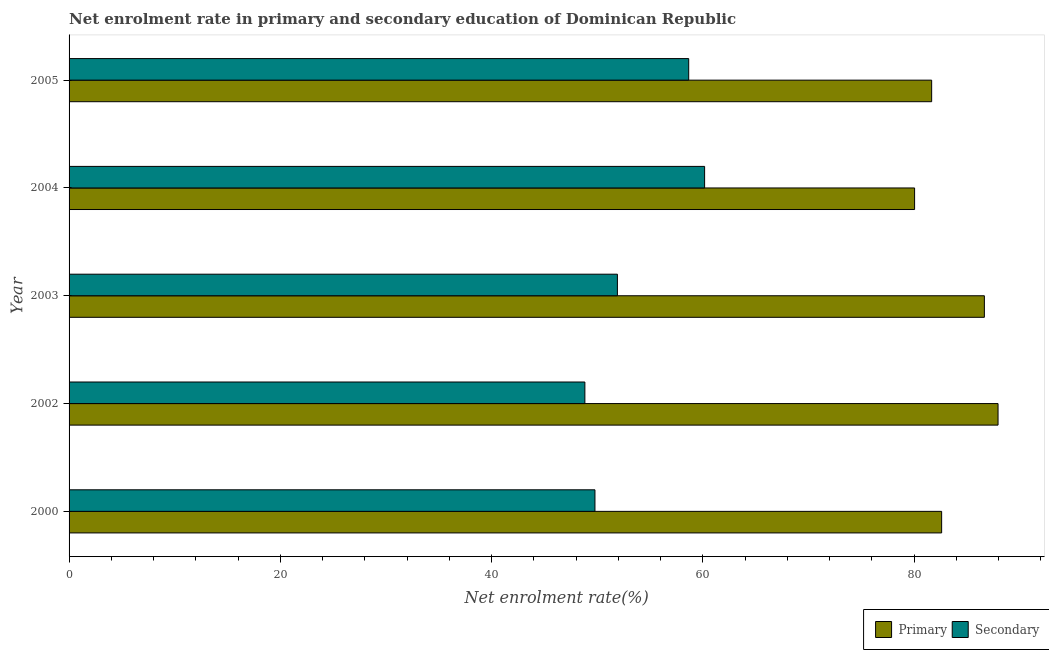What is the label of the 3rd group of bars from the top?
Offer a terse response. 2003. In how many cases, is the number of bars for a given year not equal to the number of legend labels?
Ensure brevity in your answer.  0. What is the enrollment rate in secondary education in 2005?
Offer a very short reply. 58.66. Across all years, what is the maximum enrollment rate in secondary education?
Provide a short and direct response. 60.16. Across all years, what is the minimum enrollment rate in secondary education?
Your response must be concise. 48.83. In which year was the enrollment rate in primary education maximum?
Provide a succinct answer. 2002. What is the total enrollment rate in primary education in the graph?
Offer a terse response. 418.88. What is the difference between the enrollment rate in primary education in 2004 and that in 2005?
Ensure brevity in your answer.  -1.61. What is the difference between the enrollment rate in primary education in 2000 and the enrollment rate in secondary education in 2005?
Provide a short and direct response. 23.94. What is the average enrollment rate in primary education per year?
Keep it short and to the point. 83.78. In the year 2005, what is the difference between the enrollment rate in primary education and enrollment rate in secondary education?
Offer a terse response. 23. In how many years, is the enrollment rate in primary education greater than 80 %?
Offer a terse response. 5. What is the ratio of the enrollment rate in primary education in 2002 to that in 2005?
Give a very brief answer. 1.08. Is the difference between the enrollment rate in secondary education in 2000 and 2004 greater than the difference between the enrollment rate in primary education in 2000 and 2004?
Make the answer very short. No. What is the difference between the highest and the second highest enrollment rate in primary education?
Provide a succinct answer. 1.29. What is the difference between the highest and the lowest enrollment rate in secondary education?
Provide a short and direct response. 11.33. Is the sum of the enrollment rate in primary education in 2002 and 2005 greater than the maximum enrollment rate in secondary education across all years?
Make the answer very short. Yes. What does the 2nd bar from the top in 2002 represents?
Provide a short and direct response. Primary. What does the 2nd bar from the bottom in 2004 represents?
Ensure brevity in your answer.  Secondary. Are all the bars in the graph horizontal?
Keep it short and to the point. Yes. What is the difference between two consecutive major ticks on the X-axis?
Provide a succinct answer. 20. Are the values on the major ticks of X-axis written in scientific E-notation?
Provide a short and direct response. No. Does the graph contain any zero values?
Your response must be concise. No. Does the graph contain grids?
Your answer should be very brief. No. How many legend labels are there?
Provide a short and direct response. 2. How are the legend labels stacked?
Offer a very short reply. Horizontal. What is the title of the graph?
Give a very brief answer. Net enrolment rate in primary and secondary education of Dominican Republic. What is the label or title of the X-axis?
Provide a succinct answer. Net enrolment rate(%). What is the Net enrolment rate(%) of Primary in 2000?
Offer a very short reply. 82.6. What is the Net enrolment rate(%) in Secondary in 2000?
Ensure brevity in your answer.  49.78. What is the Net enrolment rate(%) of Primary in 2002?
Your response must be concise. 87.94. What is the Net enrolment rate(%) of Secondary in 2002?
Offer a very short reply. 48.83. What is the Net enrolment rate(%) in Primary in 2003?
Provide a short and direct response. 86.64. What is the Net enrolment rate(%) of Secondary in 2003?
Provide a succinct answer. 51.91. What is the Net enrolment rate(%) in Primary in 2004?
Your answer should be very brief. 80.04. What is the Net enrolment rate(%) of Secondary in 2004?
Make the answer very short. 60.16. What is the Net enrolment rate(%) in Primary in 2005?
Offer a terse response. 81.65. What is the Net enrolment rate(%) in Secondary in 2005?
Your answer should be compact. 58.66. Across all years, what is the maximum Net enrolment rate(%) of Primary?
Keep it short and to the point. 87.94. Across all years, what is the maximum Net enrolment rate(%) of Secondary?
Give a very brief answer. 60.16. Across all years, what is the minimum Net enrolment rate(%) of Primary?
Provide a succinct answer. 80.04. Across all years, what is the minimum Net enrolment rate(%) of Secondary?
Give a very brief answer. 48.83. What is the total Net enrolment rate(%) in Primary in the graph?
Your response must be concise. 418.88. What is the total Net enrolment rate(%) of Secondary in the graph?
Your response must be concise. 269.33. What is the difference between the Net enrolment rate(%) of Primary in 2000 and that in 2002?
Offer a very short reply. -5.34. What is the difference between the Net enrolment rate(%) in Secondary in 2000 and that in 2002?
Provide a succinct answer. 0.95. What is the difference between the Net enrolment rate(%) in Primary in 2000 and that in 2003?
Give a very brief answer. -4.04. What is the difference between the Net enrolment rate(%) in Secondary in 2000 and that in 2003?
Your answer should be very brief. -2.13. What is the difference between the Net enrolment rate(%) in Primary in 2000 and that in 2004?
Ensure brevity in your answer.  2.56. What is the difference between the Net enrolment rate(%) in Secondary in 2000 and that in 2004?
Your answer should be compact. -10.38. What is the difference between the Net enrolment rate(%) of Primary in 2000 and that in 2005?
Ensure brevity in your answer.  0.95. What is the difference between the Net enrolment rate(%) in Secondary in 2000 and that in 2005?
Your answer should be compact. -8.87. What is the difference between the Net enrolment rate(%) in Primary in 2002 and that in 2003?
Offer a terse response. 1.29. What is the difference between the Net enrolment rate(%) of Secondary in 2002 and that in 2003?
Keep it short and to the point. -3.08. What is the difference between the Net enrolment rate(%) in Primary in 2002 and that in 2004?
Offer a terse response. 7.9. What is the difference between the Net enrolment rate(%) in Secondary in 2002 and that in 2004?
Ensure brevity in your answer.  -11.33. What is the difference between the Net enrolment rate(%) in Primary in 2002 and that in 2005?
Give a very brief answer. 6.28. What is the difference between the Net enrolment rate(%) in Secondary in 2002 and that in 2005?
Ensure brevity in your answer.  -9.83. What is the difference between the Net enrolment rate(%) of Primary in 2003 and that in 2004?
Give a very brief answer. 6.61. What is the difference between the Net enrolment rate(%) of Secondary in 2003 and that in 2004?
Your answer should be compact. -8.26. What is the difference between the Net enrolment rate(%) of Primary in 2003 and that in 2005?
Your answer should be compact. 4.99. What is the difference between the Net enrolment rate(%) in Secondary in 2003 and that in 2005?
Keep it short and to the point. -6.75. What is the difference between the Net enrolment rate(%) of Primary in 2004 and that in 2005?
Provide a short and direct response. -1.62. What is the difference between the Net enrolment rate(%) of Secondary in 2004 and that in 2005?
Provide a short and direct response. 1.51. What is the difference between the Net enrolment rate(%) of Primary in 2000 and the Net enrolment rate(%) of Secondary in 2002?
Provide a succinct answer. 33.77. What is the difference between the Net enrolment rate(%) in Primary in 2000 and the Net enrolment rate(%) in Secondary in 2003?
Your answer should be very brief. 30.69. What is the difference between the Net enrolment rate(%) of Primary in 2000 and the Net enrolment rate(%) of Secondary in 2004?
Give a very brief answer. 22.44. What is the difference between the Net enrolment rate(%) in Primary in 2000 and the Net enrolment rate(%) in Secondary in 2005?
Your answer should be compact. 23.94. What is the difference between the Net enrolment rate(%) in Primary in 2002 and the Net enrolment rate(%) in Secondary in 2003?
Offer a terse response. 36.03. What is the difference between the Net enrolment rate(%) in Primary in 2002 and the Net enrolment rate(%) in Secondary in 2004?
Offer a very short reply. 27.78. What is the difference between the Net enrolment rate(%) in Primary in 2002 and the Net enrolment rate(%) in Secondary in 2005?
Offer a very short reply. 29.28. What is the difference between the Net enrolment rate(%) of Primary in 2003 and the Net enrolment rate(%) of Secondary in 2004?
Provide a succinct answer. 26.48. What is the difference between the Net enrolment rate(%) of Primary in 2003 and the Net enrolment rate(%) of Secondary in 2005?
Offer a very short reply. 27.99. What is the difference between the Net enrolment rate(%) in Primary in 2004 and the Net enrolment rate(%) in Secondary in 2005?
Give a very brief answer. 21.38. What is the average Net enrolment rate(%) of Primary per year?
Your answer should be very brief. 83.78. What is the average Net enrolment rate(%) in Secondary per year?
Your answer should be very brief. 53.87. In the year 2000, what is the difference between the Net enrolment rate(%) in Primary and Net enrolment rate(%) in Secondary?
Offer a terse response. 32.82. In the year 2002, what is the difference between the Net enrolment rate(%) of Primary and Net enrolment rate(%) of Secondary?
Make the answer very short. 39.11. In the year 2003, what is the difference between the Net enrolment rate(%) of Primary and Net enrolment rate(%) of Secondary?
Your answer should be very brief. 34.74. In the year 2004, what is the difference between the Net enrolment rate(%) of Primary and Net enrolment rate(%) of Secondary?
Your answer should be compact. 19.88. In the year 2005, what is the difference between the Net enrolment rate(%) of Primary and Net enrolment rate(%) of Secondary?
Give a very brief answer. 23. What is the ratio of the Net enrolment rate(%) in Primary in 2000 to that in 2002?
Keep it short and to the point. 0.94. What is the ratio of the Net enrolment rate(%) in Secondary in 2000 to that in 2002?
Offer a terse response. 1.02. What is the ratio of the Net enrolment rate(%) in Primary in 2000 to that in 2003?
Offer a terse response. 0.95. What is the ratio of the Net enrolment rate(%) of Secondary in 2000 to that in 2003?
Keep it short and to the point. 0.96. What is the ratio of the Net enrolment rate(%) of Primary in 2000 to that in 2004?
Make the answer very short. 1.03. What is the ratio of the Net enrolment rate(%) in Secondary in 2000 to that in 2004?
Make the answer very short. 0.83. What is the ratio of the Net enrolment rate(%) of Primary in 2000 to that in 2005?
Your response must be concise. 1.01. What is the ratio of the Net enrolment rate(%) in Secondary in 2000 to that in 2005?
Provide a succinct answer. 0.85. What is the ratio of the Net enrolment rate(%) of Primary in 2002 to that in 2003?
Offer a terse response. 1.01. What is the ratio of the Net enrolment rate(%) of Secondary in 2002 to that in 2003?
Your answer should be compact. 0.94. What is the ratio of the Net enrolment rate(%) in Primary in 2002 to that in 2004?
Your response must be concise. 1.1. What is the ratio of the Net enrolment rate(%) of Secondary in 2002 to that in 2004?
Make the answer very short. 0.81. What is the ratio of the Net enrolment rate(%) in Primary in 2002 to that in 2005?
Your response must be concise. 1.08. What is the ratio of the Net enrolment rate(%) of Secondary in 2002 to that in 2005?
Provide a succinct answer. 0.83. What is the ratio of the Net enrolment rate(%) of Primary in 2003 to that in 2004?
Your response must be concise. 1.08. What is the ratio of the Net enrolment rate(%) in Secondary in 2003 to that in 2004?
Offer a terse response. 0.86. What is the ratio of the Net enrolment rate(%) of Primary in 2003 to that in 2005?
Your answer should be very brief. 1.06. What is the ratio of the Net enrolment rate(%) in Secondary in 2003 to that in 2005?
Make the answer very short. 0.88. What is the ratio of the Net enrolment rate(%) in Primary in 2004 to that in 2005?
Ensure brevity in your answer.  0.98. What is the ratio of the Net enrolment rate(%) in Secondary in 2004 to that in 2005?
Your answer should be compact. 1.03. What is the difference between the highest and the second highest Net enrolment rate(%) of Primary?
Give a very brief answer. 1.29. What is the difference between the highest and the second highest Net enrolment rate(%) in Secondary?
Your answer should be compact. 1.51. What is the difference between the highest and the lowest Net enrolment rate(%) of Primary?
Offer a terse response. 7.9. What is the difference between the highest and the lowest Net enrolment rate(%) in Secondary?
Your answer should be very brief. 11.33. 